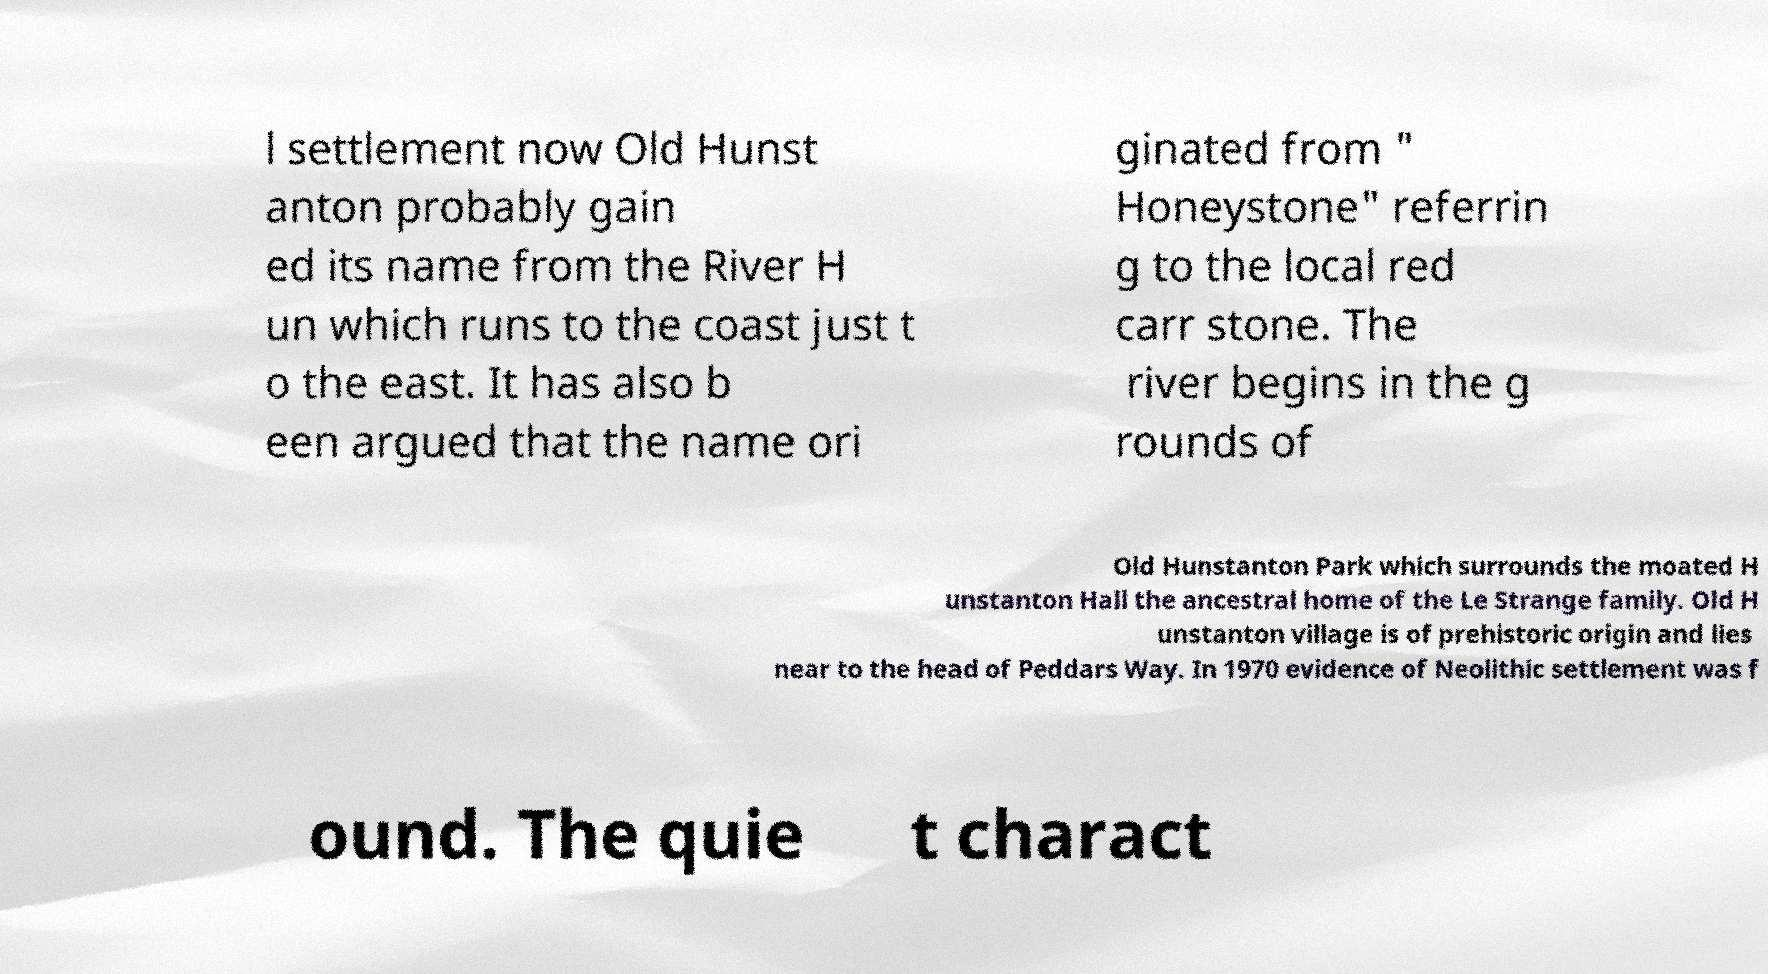Can you accurately transcribe the text from the provided image for me? l settlement now Old Hunst anton probably gain ed its name from the River H un which runs to the coast just t o the east. It has also b een argued that the name ori ginated from " Honeystone" referrin g to the local red carr stone. The river begins in the g rounds of Old Hunstanton Park which surrounds the moated H unstanton Hall the ancestral home of the Le Strange family. Old H unstanton village is of prehistoric origin and lies near to the head of Peddars Way. In 1970 evidence of Neolithic settlement was f ound. The quie t charact 